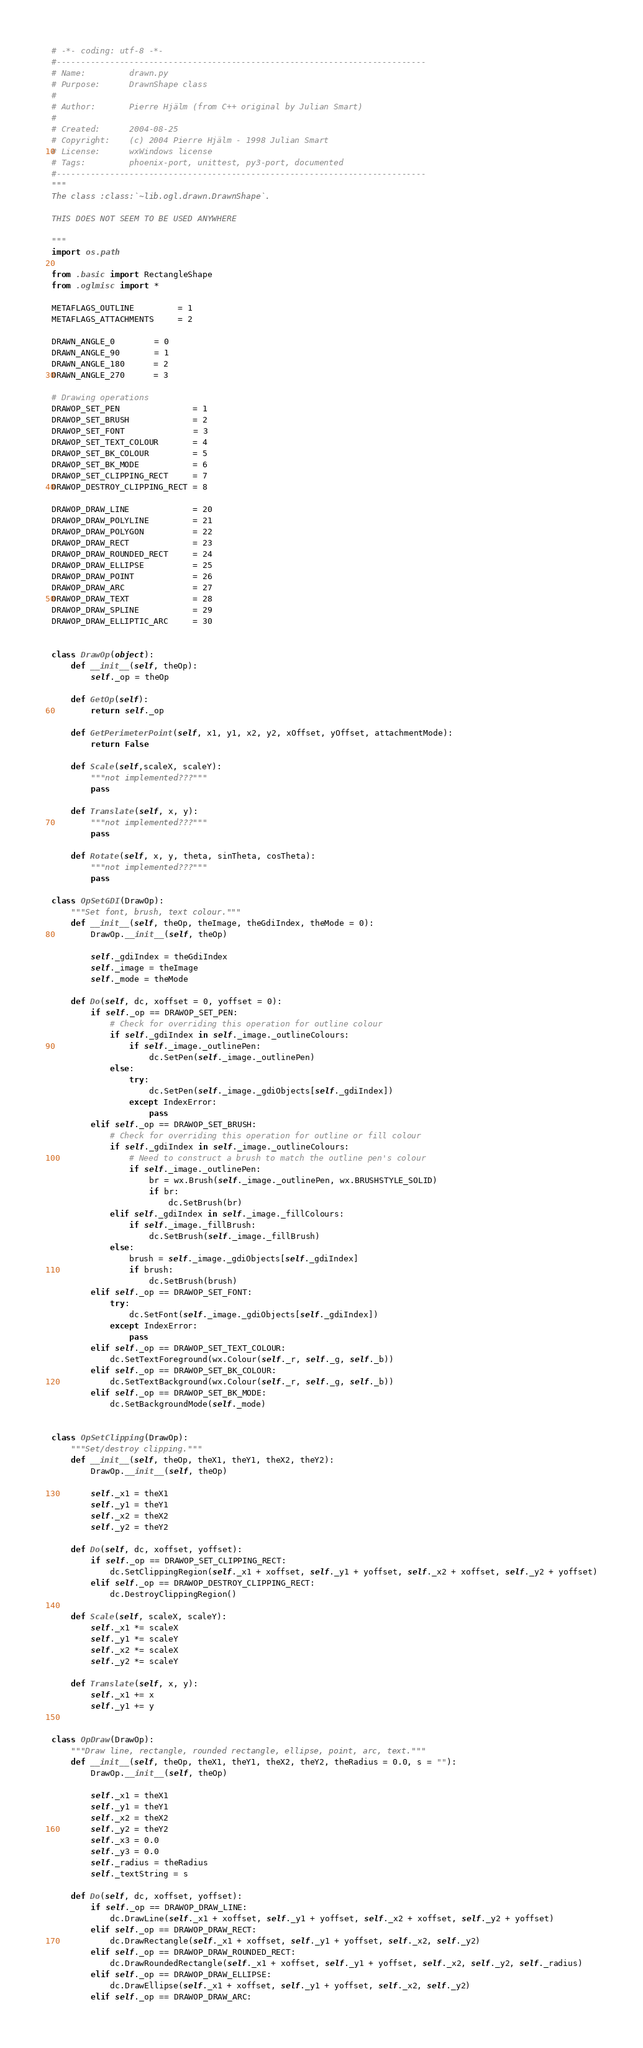Convert code to text. <code><loc_0><loc_0><loc_500><loc_500><_Python_># -*- coding: utf-8 -*-
#----------------------------------------------------------------------------
# Name:         drawn.py
# Purpose:      DrawnShape class
#
# Author:       Pierre Hjälm (from C++ original by Julian Smart)
#
# Created:      2004-08-25
# Copyright:    (c) 2004 Pierre Hjälm - 1998 Julian Smart
# License:      wxWindows license
# Tags:         phoenix-port, unittest, py3-port, documented
#----------------------------------------------------------------------------
"""
The class :class:`~lib.ogl.drawn.DrawnShape`.

THIS DOES NOT SEEM TO BE USED ANYWHERE

"""
import os.path

from .basic import RectangleShape
from .oglmisc import *

METAFLAGS_OUTLINE         = 1
METAFLAGS_ATTACHMENTS     = 2

DRAWN_ANGLE_0        = 0
DRAWN_ANGLE_90       = 1
DRAWN_ANGLE_180      = 2
DRAWN_ANGLE_270      = 3

# Drawing operations
DRAWOP_SET_PEN               = 1
DRAWOP_SET_BRUSH             = 2
DRAWOP_SET_FONT              = 3
DRAWOP_SET_TEXT_COLOUR       = 4
DRAWOP_SET_BK_COLOUR         = 5
DRAWOP_SET_BK_MODE           = 6
DRAWOP_SET_CLIPPING_RECT     = 7
DRAWOP_DESTROY_CLIPPING_RECT = 8

DRAWOP_DRAW_LINE             = 20
DRAWOP_DRAW_POLYLINE         = 21
DRAWOP_DRAW_POLYGON          = 22
DRAWOP_DRAW_RECT             = 23
DRAWOP_DRAW_ROUNDED_RECT     = 24
DRAWOP_DRAW_ELLIPSE          = 25
DRAWOP_DRAW_POINT            = 26
DRAWOP_DRAW_ARC              = 27
DRAWOP_DRAW_TEXT             = 28
DRAWOP_DRAW_SPLINE           = 29
DRAWOP_DRAW_ELLIPTIC_ARC     = 30


class DrawOp(object):
    def __init__(self, theOp):
        self._op = theOp

    def GetOp(self):
        return self._op

    def GetPerimeterPoint(self, x1, y1, x2, y2, xOffset, yOffset, attachmentMode):
        return False

    def Scale(self,scaleX, scaleY):
        """not implemented???"""
        pass

    def Translate(self, x, y):
        """not implemented???"""
        pass

    def Rotate(self, x, y, theta, sinTheta, cosTheta):
        """not implemented???"""
        pass

class OpSetGDI(DrawOp):
    """Set font, brush, text colour."""
    def __init__(self, theOp, theImage, theGdiIndex, theMode = 0):
        DrawOp.__init__(self, theOp)

        self._gdiIndex = theGdiIndex
        self._image = theImage
        self._mode = theMode

    def Do(self, dc, xoffset = 0, yoffset = 0):
        if self._op == DRAWOP_SET_PEN:
            # Check for overriding this operation for outline colour
            if self._gdiIndex in self._image._outlineColours:
                if self._image._outlinePen:
                    dc.SetPen(self._image._outlinePen)
            else:
                try:
                    dc.SetPen(self._image._gdiObjects[self._gdiIndex])
                except IndexError:
                    pass
        elif self._op == DRAWOP_SET_BRUSH:
            # Check for overriding this operation for outline or fill colour
            if self._gdiIndex in self._image._outlineColours:
                # Need to construct a brush to match the outline pen's colour
                if self._image._outlinePen:
                    br = wx.Brush(self._image._outlinePen, wx.BRUSHSTYLE_SOLID)
                    if br:
                        dc.SetBrush(br)
            elif self._gdiIndex in self._image._fillColours:
                if self._image._fillBrush:
                    dc.SetBrush(self._image._fillBrush)
            else:
                brush = self._image._gdiObjects[self._gdiIndex]
                if brush:
                    dc.SetBrush(brush)
        elif self._op == DRAWOP_SET_FONT:
            try:
                dc.SetFont(self._image._gdiObjects[self._gdiIndex])
            except IndexError:
                pass
        elif self._op == DRAWOP_SET_TEXT_COLOUR:
            dc.SetTextForeground(wx.Colour(self._r, self._g, self._b))
        elif self._op == DRAWOP_SET_BK_COLOUR:
            dc.SetTextBackground(wx.Colour(self._r, self._g, self._b))
        elif self._op == DRAWOP_SET_BK_MODE:
            dc.SetBackgroundMode(self._mode)


class OpSetClipping(DrawOp):
    """Set/destroy clipping."""
    def __init__(self, theOp, theX1, theY1, theX2, theY2):
        DrawOp.__init__(self, theOp)

        self._x1 = theX1
        self._y1 = theY1
        self._x2 = theX2
        self._y2 = theY2

    def Do(self, dc, xoffset, yoffset):
        if self._op == DRAWOP_SET_CLIPPING_RECT:
            dc.SetClippingRegion(self._x1 + xoffset, self._y1 + yoffset, self._x2 + xoffset, self._y2 + yoffset)
        elif self._op == DRAWOP_DESTROY_CLIPPING_RECT:
            dc.DestroyClippingRegion()

    def Scale(self, scaleX, scaleY):
        self._x1 *= scaleX
        self._y1 *= scaleY
        self._x2 *= scaleX
        self._y2 *= scaleY

    def Translate(self, x, y):
        self._x1 += x
        self._y1 += y


class OpDraw(DrawOp):
    """Draw line, rectangle, rounded rectangle, ellipse, point, arc, text."""
    def __init__(self, theOp, theX1, theY1, theX2, theY2, theRadius = 0.0, s = ""):
        DrawOp.__init__(self, theOp)

        self._x1 = theX1
        self._y1 = theY1
        self._x2 = theX2
        self._y2 = theY2
        self._x3 = 0.0
        self._y3 = 0.0
        self._radius = theRadius
        self._textString = s

    def Do(self, dc, xoffset, yoffset):
        if self._op == DRAWOP_DRAW_LINE:
            dc.DrawLine(self._x1 + xoffset, self._y1 + yoffset, self._x2 + xoffset, self._y2 + yoffset)
        elif self._op == DRAWOP_DRAW_RECT:
            dc.DrawRectangle(self._x1 + xoffset, self._y1 + yoffset, self._x2, self._y2)
        elif self._op == DRAWOP_DRAW_ROUNDED_RECT:
            dc.DrawRoundedRectangle(self._x1 + xoffset, self._y1 + yoffset, self._x2, self._y2, self._radius)
        elif self._op == DRAWOP_DRAW_ELLIPSE:
            dc.DrawEllipse(self._x1 + xoffset, self._y1 + yoffset, self._x2, self._y2)
        elif self._op == DRAWOP_DRAW_ARC:</code> 